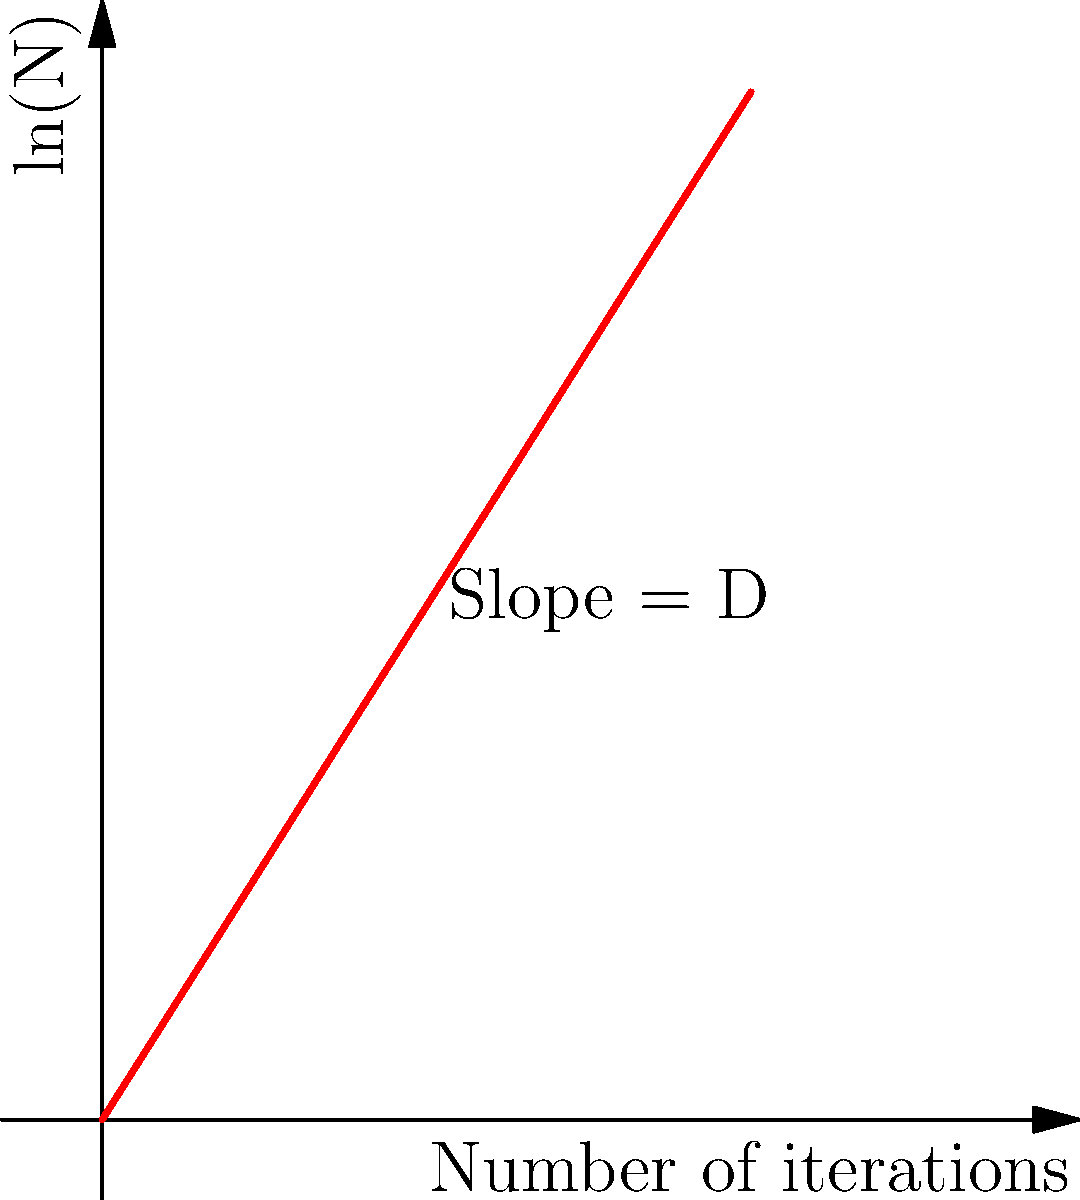Given the graph showing the relationship between the logarithm of the number of segments (ln(N)) and the number of iterations in a box-counting method for calculating the fractal dimension of forest patch boundaries, determine the fractal dimension D. Assume the slope of the line represents the fractal dimension. To calculate the fractal dimension D from the given graph, we need to follow these steps:

1. Recognize that the fractal dimension D is represented by the slope of the line in the graph.

2. To calculate the slope, we need to use two points on the line. Let's choose the points (0, 0) and (5, 7.92).

3. Use the slope formula:
   $$D = \frac{y_2 - y_1}{x_2 - x_1}$$

4. Plug in the values:
   $$D = \frac{7.92 - 0}{5 - 0} = \frac{7.92}{5}$$

5. Simplify:
   $$D = 1.584$$

Therefore, the fractal dimension of the forest patch boundaries is approximately 1.584.

This value indicates that the forest patch boundaries are more complex than a simple line (which would have a dimension of 1) but less complex than a filled 2D shape (which would have a dimension of 2). This fractal dimension suggests a moderately complex edge structure, which could be indicative of natural forest boundaries or managed forest edges with some level of complexity.
Answer: $D \approx 1.584$ 